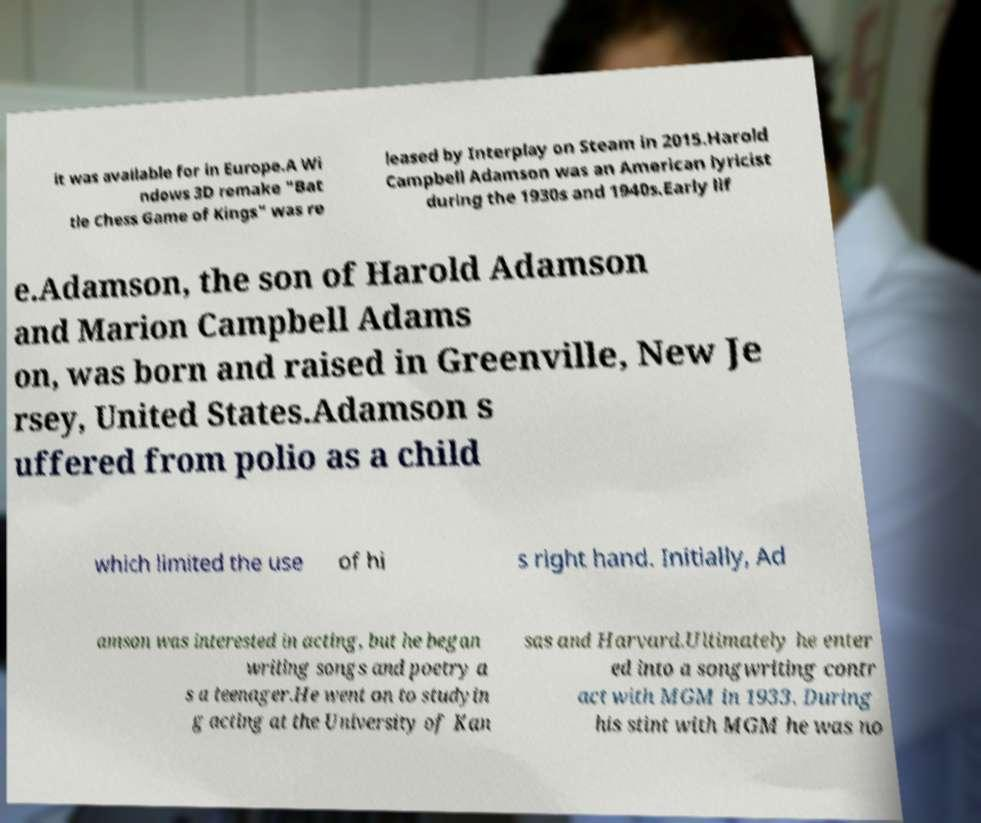Could you extract and type out the text from this image? it was available for in Europe.A Wi ndows 3D remake "Bat tle Chess Game of Kings" was re leased by Interplay on Steam in 2015.Harold Campbell Adamson was an American lyricist during the 1930s and 1940s.Early lif e.Adamson, the son of Harold Adamson and Marion Campbell Adams on, was born and raised in Greenville, New Je rsey, United States.Adamson s uffered from polio as a child which limited the use of hi s right hand. Initially, Ad amson was interested in acting, but he began writing songs and poetry a s a teenager.He went on to studyin g acting at the University of Kan sas and Harvard.Ultimately he enter ed into a songwriting contr act with MGM in 1933. During his stint with MGM he was no 